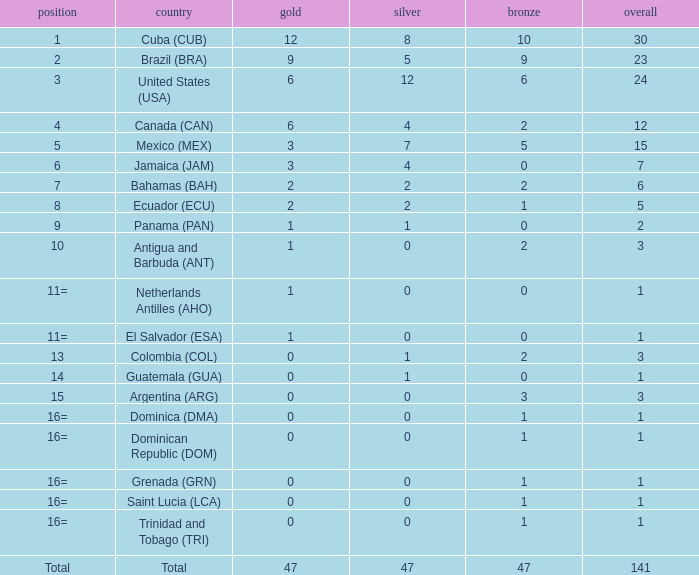What is the average silver with more than 0 gold, a Rank of 1, and a Total smaller than 30? None. 